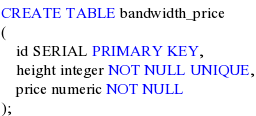Convert code to text. <code><loc_0><loc_0><loc_500><loc_500><_SQL_>CREATE TABLE bandwidth_price
(
    id SERIAL PRIMARY KEY,
    height integer NOT NULL UNIQUE,
    price numeric NOT NULL
);</code> 